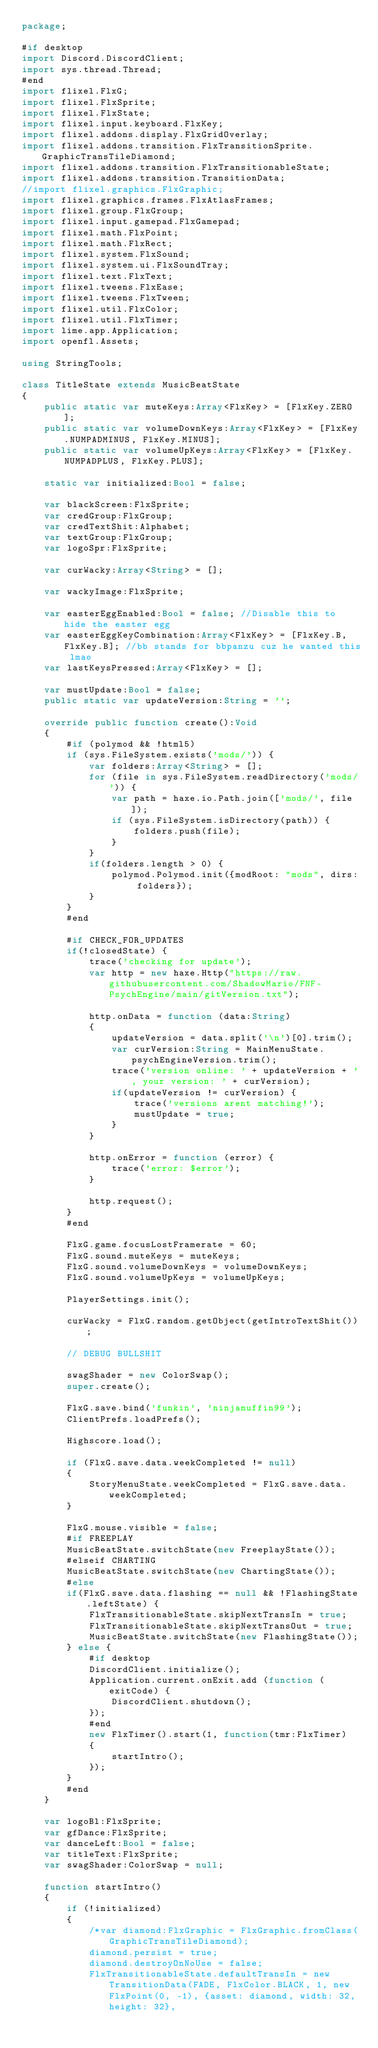<code> <loc_0><loc_0><loc_500><loc_500><_Haxe_>package;

#if desktop
import Discord.DiscordClient;
import sys.thread.Thread;
#end
import flixel.FlxG;
import flixel.FlxSprite;
import flixel.FlxState;
import flixel.input.keyboard.FlxKey;
import flixel.addons.display.FlxGridOverlay;
import flixel.addons.transition.FlxTransitionSprite.GraphicTransTileDiamond;
import flixel.addons.transition.FlxTransitionableState;
import flixel.addons.transition.TransitionData;
//import flixel.graphics.FlxGraphic;
import flixel.graphics.frames.FlxAtlasFrames;
import flixel.group.FlxGroup;
import flixel.input.gamepad.FlxGamepad;
import flixel.math.FlxPoint;
import flixel.math.FlxRect;
import flixel.system.FlxSound;
import flixel.system.ui.FlxSoundTray;
import flixel.text.FlxText;
import flixel.tweens.FlxEase;
import flixel.tweens.FlxTween;
import flixel.util.FlxColor;
import flixel.util.FlxTimer;
import lime.app.Application;
import openfl.Assets;

using StringTools;

class TitleState extends MusicBeatState
{
	public static var muteKeys:Array<FlxKey> = [FlxKey.ZERO];
	public static var volumeDownKeys:Array<FlxKey> = [FlxKey.NUMPADMINUS, FlxKey.MINUS];
	public static var volumeUpKeys:Array<FlxKey> = [FlxKey.NUMPADPLUS, FlxKey.PLUS];

	static var initialized:Bool = false;

	var blackScreen:FlxSprite;
	var credGroup:FlxGroup;
	var credTextShit:Alphabet;
	var textGroup:FlxGroup;
	var logoSpr:FlxSprite;

	var curWacky:Array<String> = [];

	var wackyImage:FlxSprite;

	var easterEggEnabled:Bool = false; //Disable this to hide the easter egg
	var easterEggKeyCombination:Array<FlxKey> = [FlxKey.B, FlxKey.B]; //bb stands for bbpanzu cuz he wanted this lmao
	var lastKeysPressed:Array<FlxKey> = [];

	var mustUpdate:Bool = false;
	public static var updateVersion:String = '';

	override public function create():Void
	{
		#if (polymod && !html5)
		if (sys.FileSystem.exists('mods/')) {
			var folders:Array<String> = [];
			for (file in sys.FileSystem.readDirectory('mods/')) {
				var path = haxe.io.Path.join(['mods/', file]);
				if (sys.FileSystem.isDirectory(path)) {
					folders.push(file);
				}
			}
			if(folders.length > 0) {
				polymod.Polymod.init({modRoot: "mods", dirs: folders});
			}
		}
		#end
		
		#if CHECK_FOR_UPDATES
		if(!closedState) {
			trace('checking for update');
			var http = new haxe.Http("https://raw.githubusercontent.com/ShadowMario/FNF-PsychEngine/main/gitVersion.txt");
			
			http.onData = function (data:String)
			{
				updateVersion = data.split('\n')[0].trim();
				var curVersion:String = MainMenuState.psychEngineVersion.trim();
				trace('version online: ' + updateVersion + ', your version: ' + curVersion);
				if(updateVersion != curVersion) {
					trace('versions arent matching!');
					mustUpdate = true;
				}
			}
			
			http.onError = function (error) {
				trace('error: $error');
			}
			
			http.request();
		}
		#end

		FlxG.game.focusLostFramerate = 60;
		FlxG.sound.muteKeys = muteKeys;
		FlxG.sound.volumeDownKeys = volumeDownKeys;
		FlxG.sound.volumeUpKeys = volumeUpKeys;

		PlayerSettings.init();

		curWacky = FlxG.random.getObject(getIntroTextShit());

		// DEBUG BULLSHIT

		swagShader = new ColorSwap();
		super.create();

		FlxG.save.bind('funkin', 'ninjamuffin99');
		ClientPrefs.loadPrefs();

		Highscore.load();

		if (FlxG.save.data.weekCompleted != null)
		{
			StoryMenuState.weekCompleted = FlxG.save.data.weekCompleted;
		}

		FlxG.mouse.visible = false;
		#if FREEPLAY
		MusicBeatState.switchState(new FreeplayState());
		#elseif CHARTING
		MusicBeatState.switchState(new ChartingState());
		#else
		if(FlxG.save.data.flashing == null && !FlashingState.leftState) {
			FlxTransitionableState.skipNextTransIn = true;
			FlxTransitionableState.skipNextTransOut = true;
			MusicBeatState.switchState(new FlashingState());
		} else {
			#if desktop
			DiscordClient.initialize();
			Application.current.onExit.add (function (exitCode) {
				DiscordClient.shutdown();
			});
			#end
			new FlxTimer().start(1, function(tmr:FlxTimer)
			{
				startIntro();
			});
		}
		#end
	}

	var logoBl:FlxSprite;
	var gfDance:FlxSprite;
	var danceLeft:Bool = false;
	var titleText:FlxSprite;
	var swagShader:ColorSwap = null;

	function startIntro()
	{
		if (!initialized)
		{
			/*var diamond:FlxGraphic = FlxGraphic.fromClass(GraphicTransTileDiamond);
			diamond.persist = true;
			diamond.destroyOnNoUse = false;
			FlxTransitionableState.defaultTransIn = new TransitionData(FADE, FlxColor.BLACK, 1, new FlxPoint(0, -1), {asset: diamond, width: 32, height: 32},</code> 